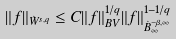<formula> <loc_0><loc_0><loc_500><loc_500>\| f \| _ { \dot { W } ^ { s , q } } \leq C \| f \| _ { B V } ^ { 1 / q } \| f \| _ { \dot { B } ^ { - \beta , \infty } _ { \infty } } ^ { 1 - 1 / q }</formula> 